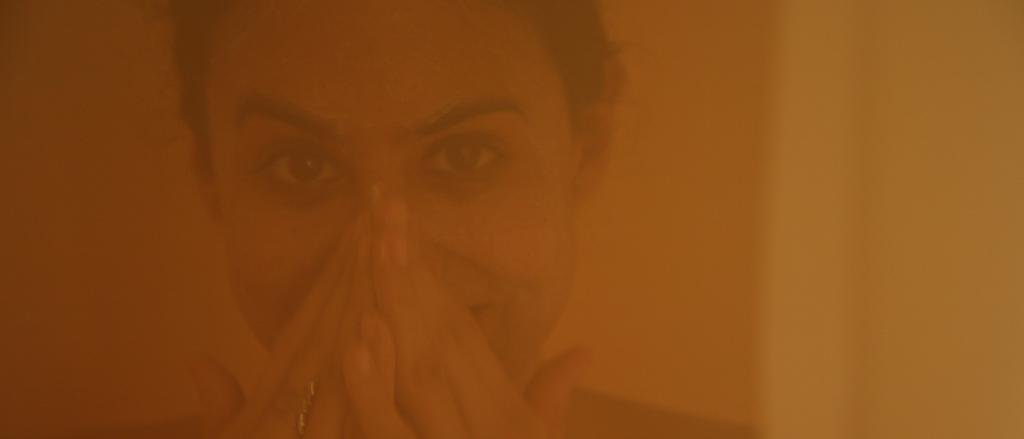What is the main subject of the image? There is a person's face in the image. Can you describe the color scheme of the image? The image has orange and yellow colors. What type of legal advice is the person in the image seeking? There is no indication in the image that the person is seeking legal advice or interacting with a lawyer. 